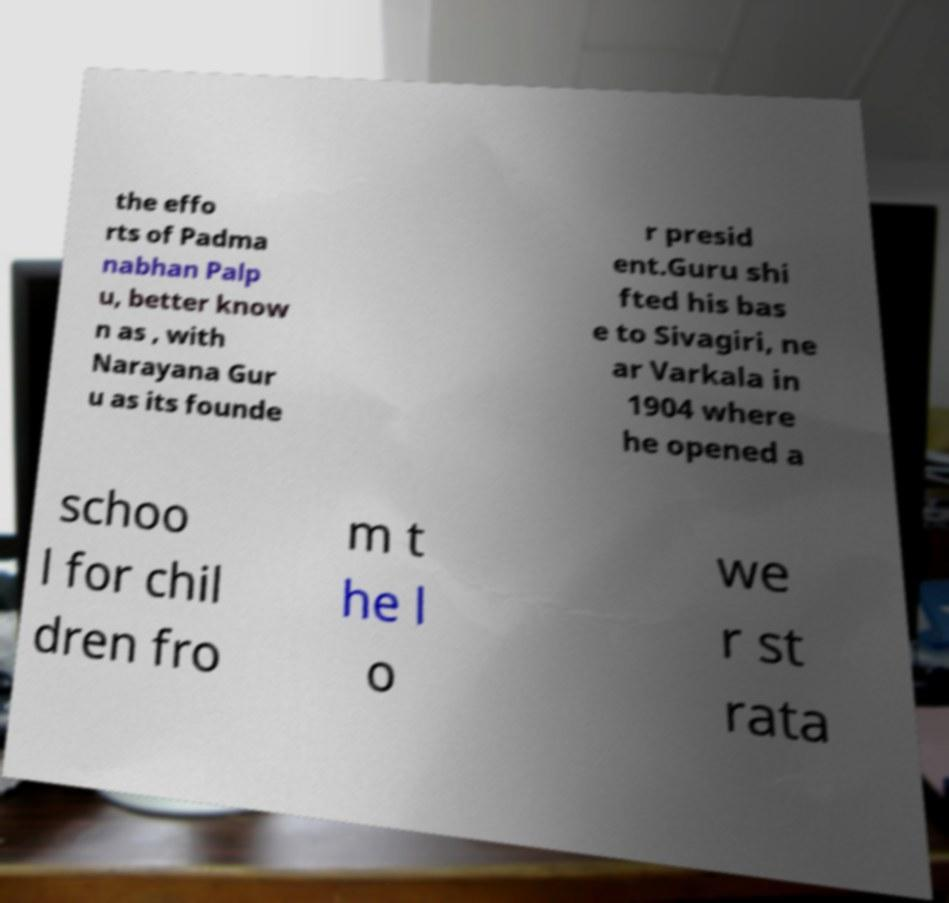Can you accurately transcribe the text from the provided image for me? the effo rts of Padma nabhan Palp u, better know n as , with Narayana Gur u as its founde r presid ent.Guru shi fted his bas e to Sivagiri, ne ar Varkala in 1904 where he opened a schoo l for chil dren fro m t he l o we r st rata 